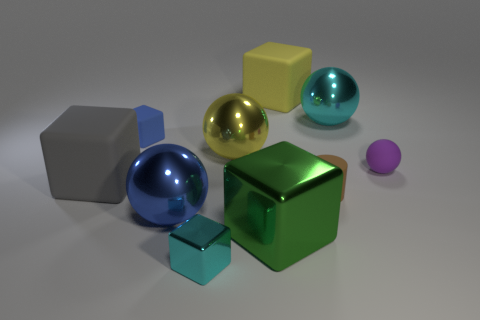Subtract 2 cubes. How many cubes are left? 3 Subtract all green cubes. How many cubes are left? 4 Subtract all yellow blocks. How many blocks are left? 4 Subtract all purple cubes. Subtract all yellow spheres. How many cubes are left? 5 Subtract all spheres. How many objects are left? 6 Subtract 1 brown cylinders. How many objects are left? 9 Subtract all yellow rubber blocks. Subtract all large gray shiny balls. How many objects are left? 9 Add 4 small spheres. How many small spheres are left? 5 Add 9 large yellow cubes. How many large yellow cubes exist? 10 